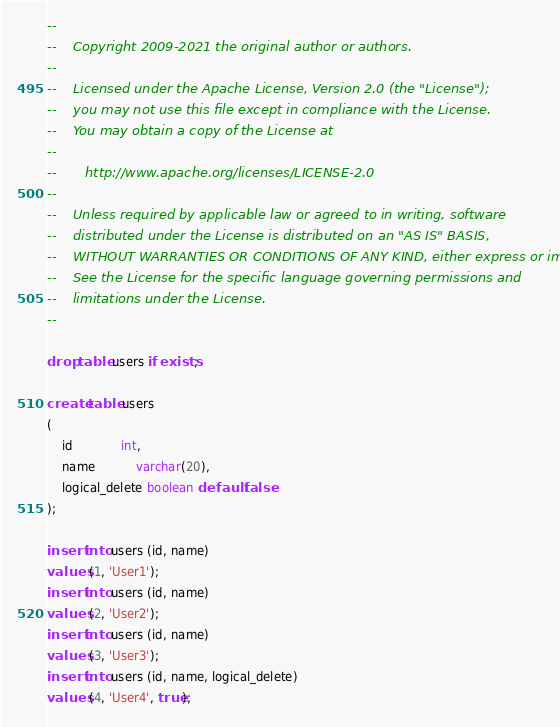Convert code to text. <code><loc_0><loc_0><loc_500><loc_500><_SQL_>--
--    Copyright 2009-2021 the original author or authors.
--
--    Licensed under the Apache License, Version 2.0 (the "License");
--    you may not use this file except in compliance with the License.
--    You may obtain a copy of the License at
--
--       http://www.apache.org/licenses/LICENSE-2.0
--
--    Unless required by applicable law or agreed to in writing, software
--    distributed under the License is distributed on an "AS IS" BASIS,
--    WITHOUT WARRANTIES OR CONDITIONS OF ANY KIND, either express or implied.
--    See the License for the specific language governing permissions and
--    limitations under the License.
--

drop table users if exists;

create table users
(
    id             int,
    name           varchar(20),
    logical_delete boolean default false
);

insert into users (id, name)
values (1, 'User1');
insert into users (id, name)
values (2, 'User2');
insert into users (id, name)
values (3, 'User3');
insert into users (id, name, logical_delete)
values (4, 'User4', true);

</code> 